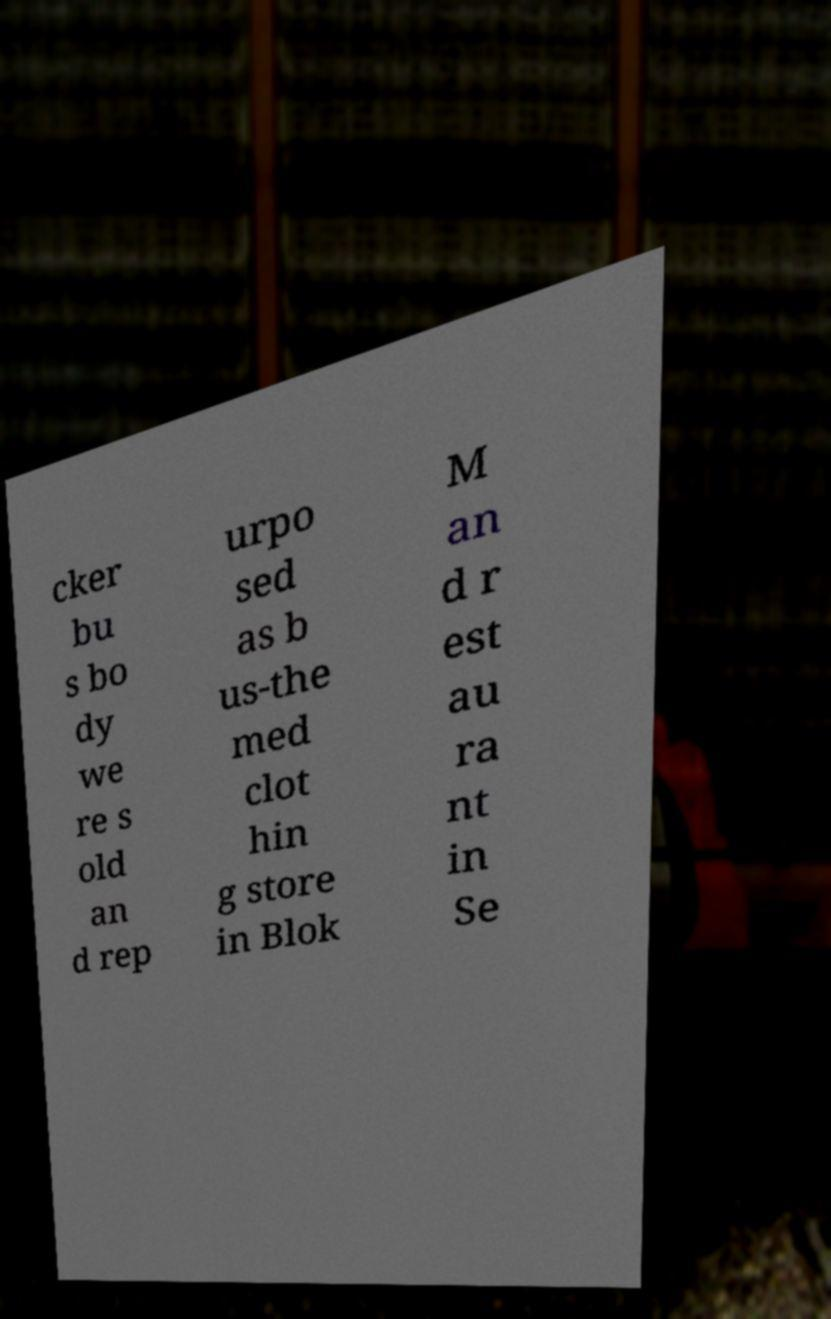There's text embedded in this image that I need extracted. Can you transcribe it verbatim? cker bu s bo dy we re s old an d rep urpo sed as b us-the med clot hin g store in Blok M an d r est au ra nt in Se 